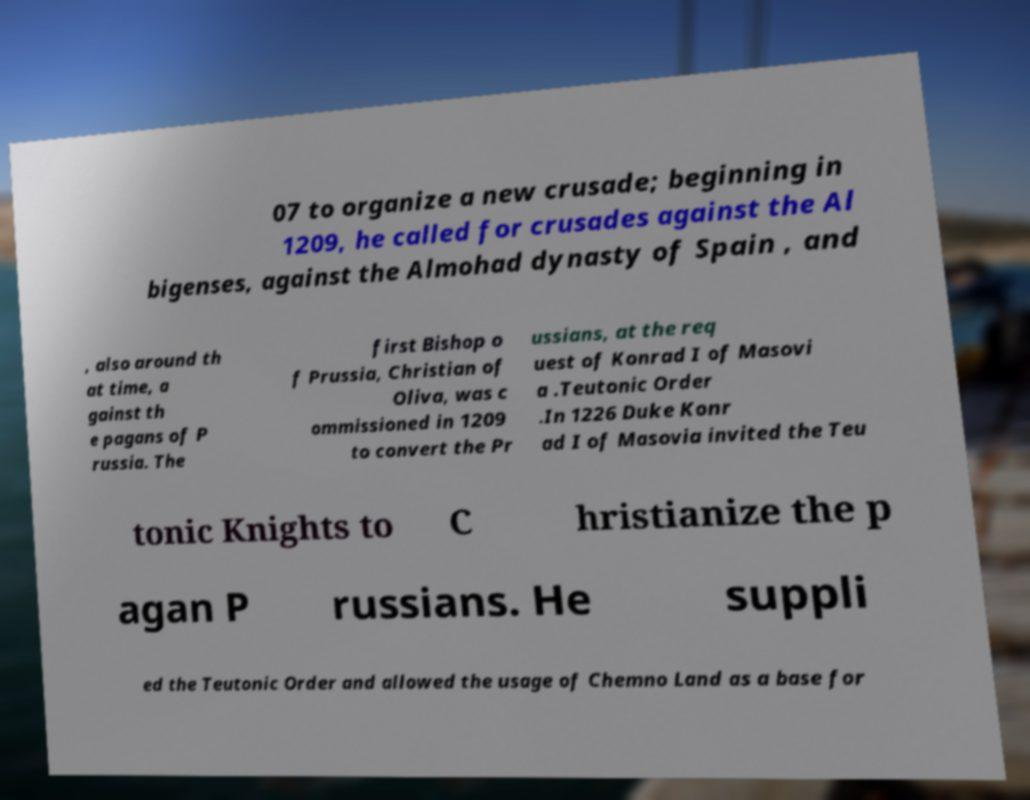Please read and relay the text visible in this image. What does it say? 07 to organize a new crusade; beginning in 1209, he called for crusades against the Al bigenses, against the Almohad dynasty of Spain , and , also around th at time, a gainst th e pagans of P russia. The first Bishop o f Prussia, Christian of Oliva, was c ommissioned in 1209 to convert the Pr ussians, at the req uest of Konrad I of Masovi a .Teutonic Order .In 1226 Duke Konr ad I of Masovia invited the Teu tonic Knights to C hristianize the p agan P russians. He suppli ed the Teutonic Order and allowed the usage of Chemno Land as a base for 